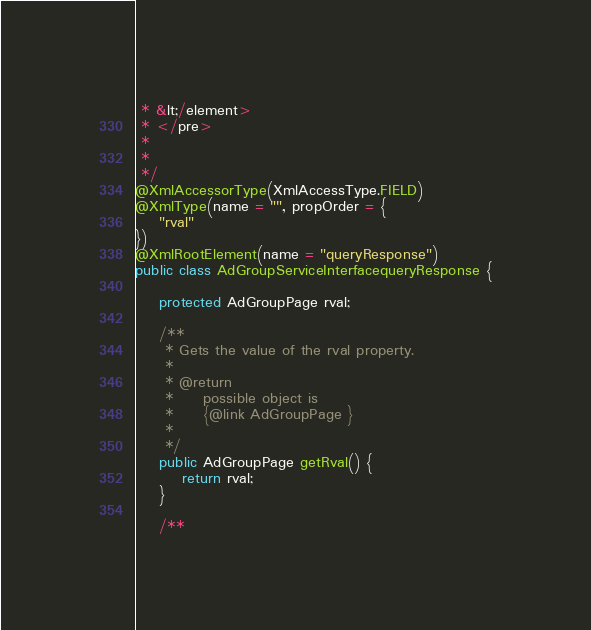<code> <loc_0><loc_0><loc_500><loc_500><_Java_> * &lt;/element>
 * </pre>
 * 
 * 
 */
@XmlAccessorType(XmlAccessType.FIELD)
@XmlType(name = "", propOrder = {
    "rval"
})
@XmlRootElement(name = "queryResponse")
public class AdGroupServiceInterfacequeryResponse {

    protected AdGroupPage rval;

    /**
     * Gets the value of the rval property.
     * 
     * @return
     *     possible object is
     *     {@link AdGroupPage }
     *     
     */
    public AdGroupPage getRval() {
        return rval;
    }

    /**</code> 